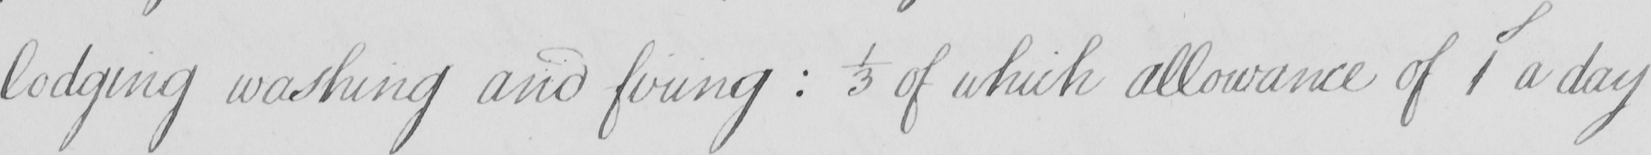What is written in this line of handwriting? lodging washing and firing  :  1/3 of which allowance of 1S a day 